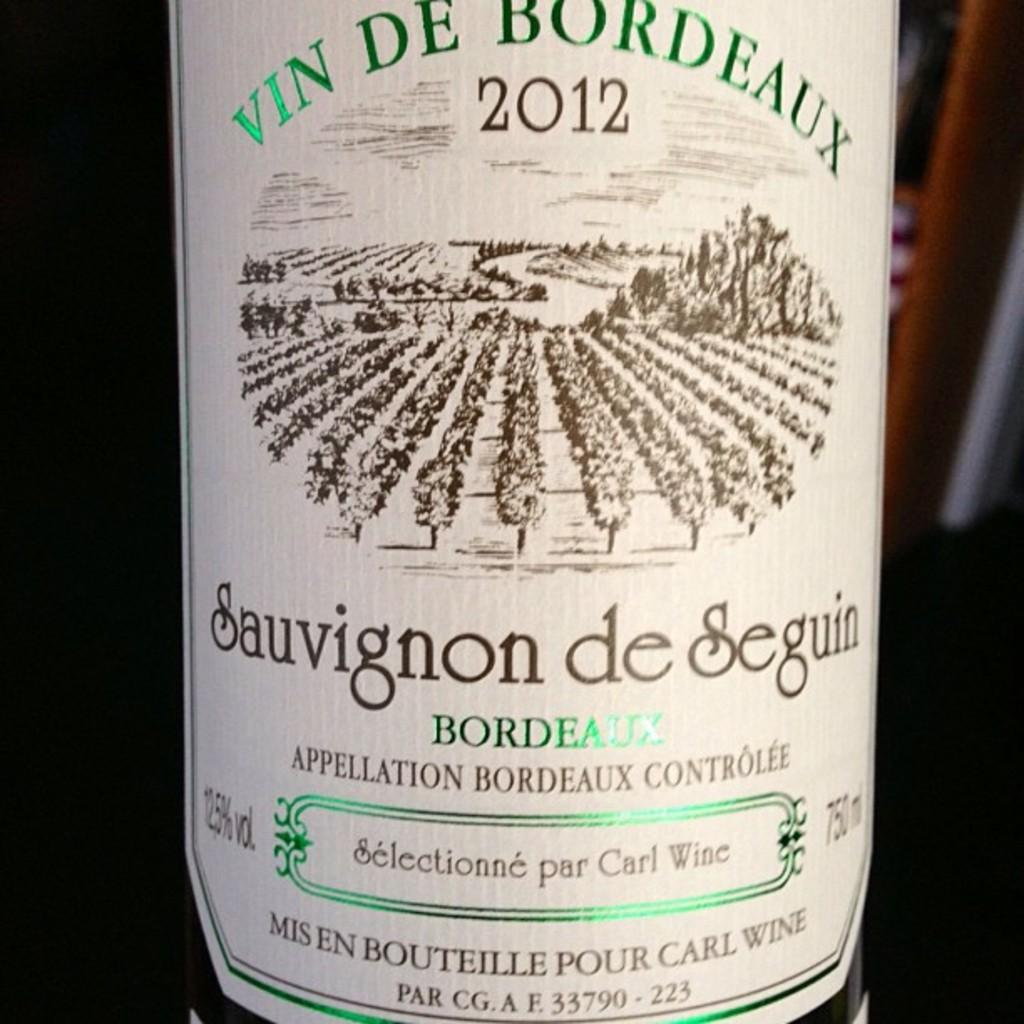<image>
Create a compact narrative representing the image presented. A label on a Sauvignon de Seguin Bordeaux from 2012. 